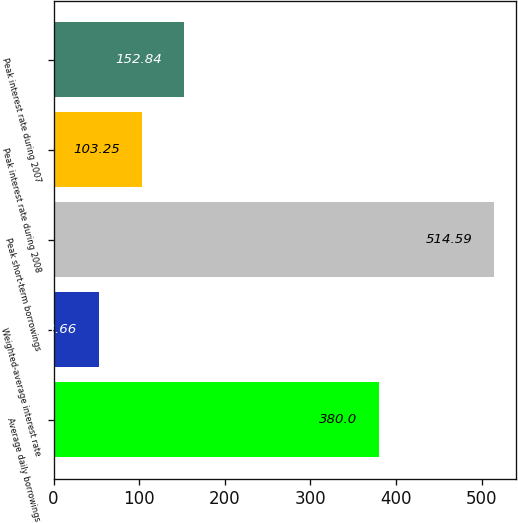Convert chart. <chart><loc_0><loc_0><loc_500><loc_500><bar_chart><fcel>Average daily borrowings<fcel>Weighted-average interest rate<fcel>Peak short-term borrowings<fcel>Peak interest rate during 2008<fcel>Peak interest rate during 2007<nl><fcel>380<fcel>53.66<fcel>514.59<fcel>103.25<fcel>152.84<nl></chart> 